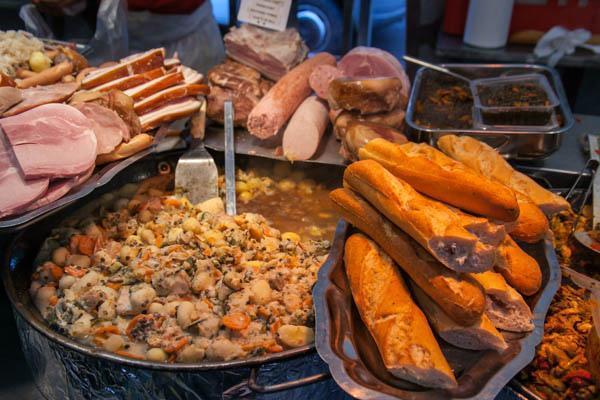Is the given caption "The person is touching the bowl." fitting for the image?
Answer yes or no. No. 